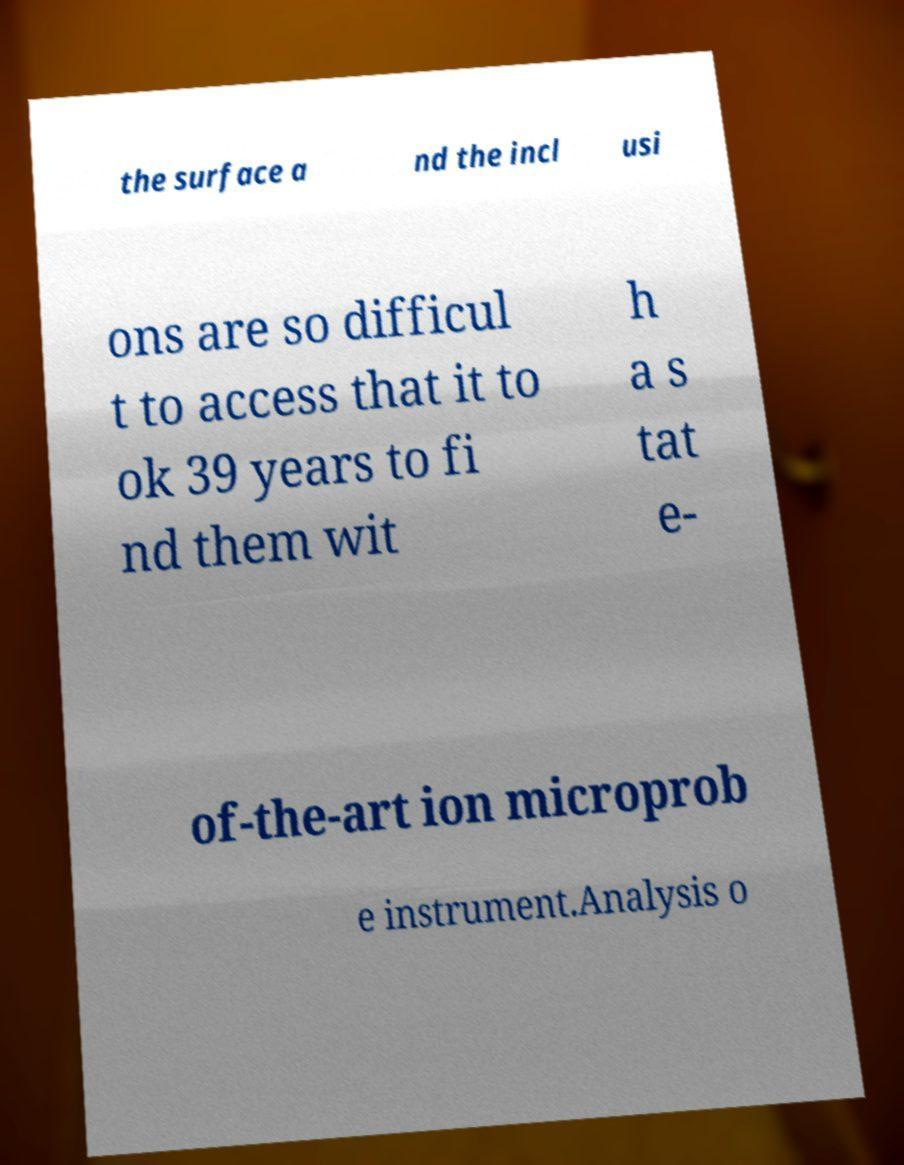What messages or text are displayed in this image? I need them in a readable, typed format. the surface a nd the incl usi ons are so difficul t to access that it to ok 39 years to fi nd them wit h a s tat e- of-the-art ion microprob e instrument.Analysis o 